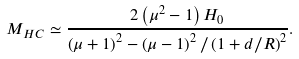Convert formula to latex. <formula><loc_0><loc_0><loc_500><loc_500>M _ { H C } \simeq \frac { 2 \left ( \mu ^ { 2 } - 1 \right ) H _ { 0 } } { \left ( \mu + 1 \right ) ^ { 2 } - \left ( \mu - 1 \right ) ^ { 2 } / \left ( 1 + d / R \right ) ^ { 2 } } .</formula> 